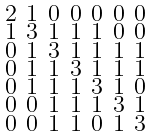Convert formula to latex. <formula><loc_0><loc_0><loc_500><loc_500>\begin{smallmatrix} 2 & 1 & 0 & 0 & 0 & 0 & 0 \\ 1 & 3 & 1 & 1 & 1 & 0 & 0 \\ 0 & 1 & 3 & 1 & 1 & 1 & 1 \\ 0 & 1 & 1 & 3 & 1 & 1 & 1 \\ 0 & 1 & 1 & 1 & 3 & 1 & 0 \\ 0 & 0 & 1 & 1 & 1 & 3 & 1 \\ 0 & 0 & 1 & 1 & 0 & 1 & 3 \end{smallmatrix}</formula> 